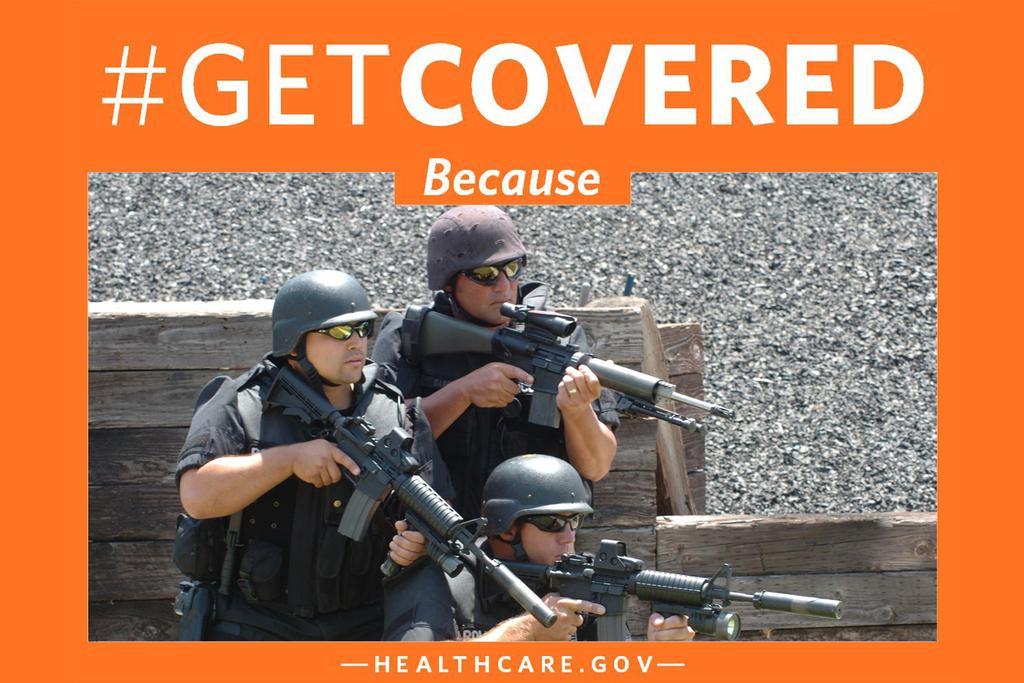Could you give a brief overview of what you see in this image? In this image we can see there are three people holding guns and wearing helmet 